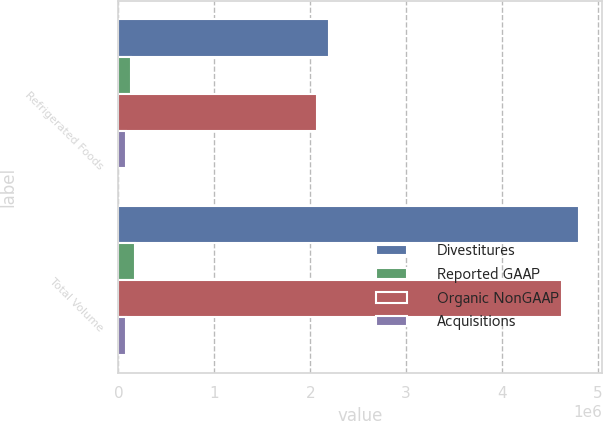Convert chart. <chart><loc_0><loc_0><loc_500><loc_500><stacked_bar_chart><ecel><fcel>Refrigerated Foods<fcel>Total Volume<nl><fcel>Divestitures<fcel>2.19999e+06<fcel>4.79818e+06<nl><fcel>Reported GAAP<fcel>130301<fcel>176008<nl><fcel>Organic NonGAAP<fcel>2.06969e+06<fcel>4.62217e+06<nl><fcel>Acquisitions<fcel>80454<fcel>80454<nl></chart> 